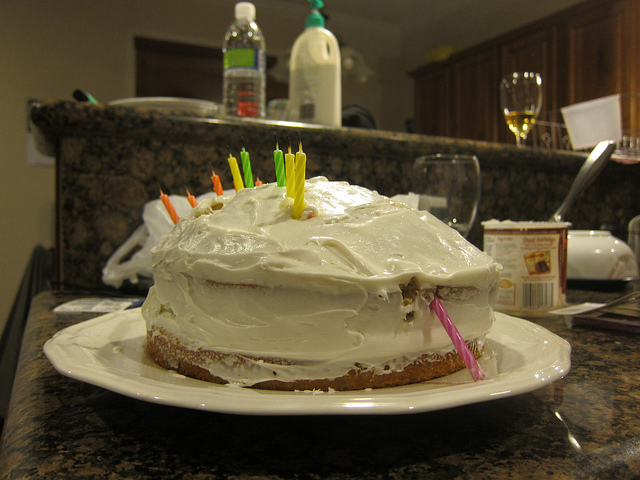How many cakes are there? There is one cake in the image. It is placed on a white plate and appears to be a homemade, two-layer cake with white frosting. There are several colorful candles on top, which could suggest a celebration or birthday occasion. 